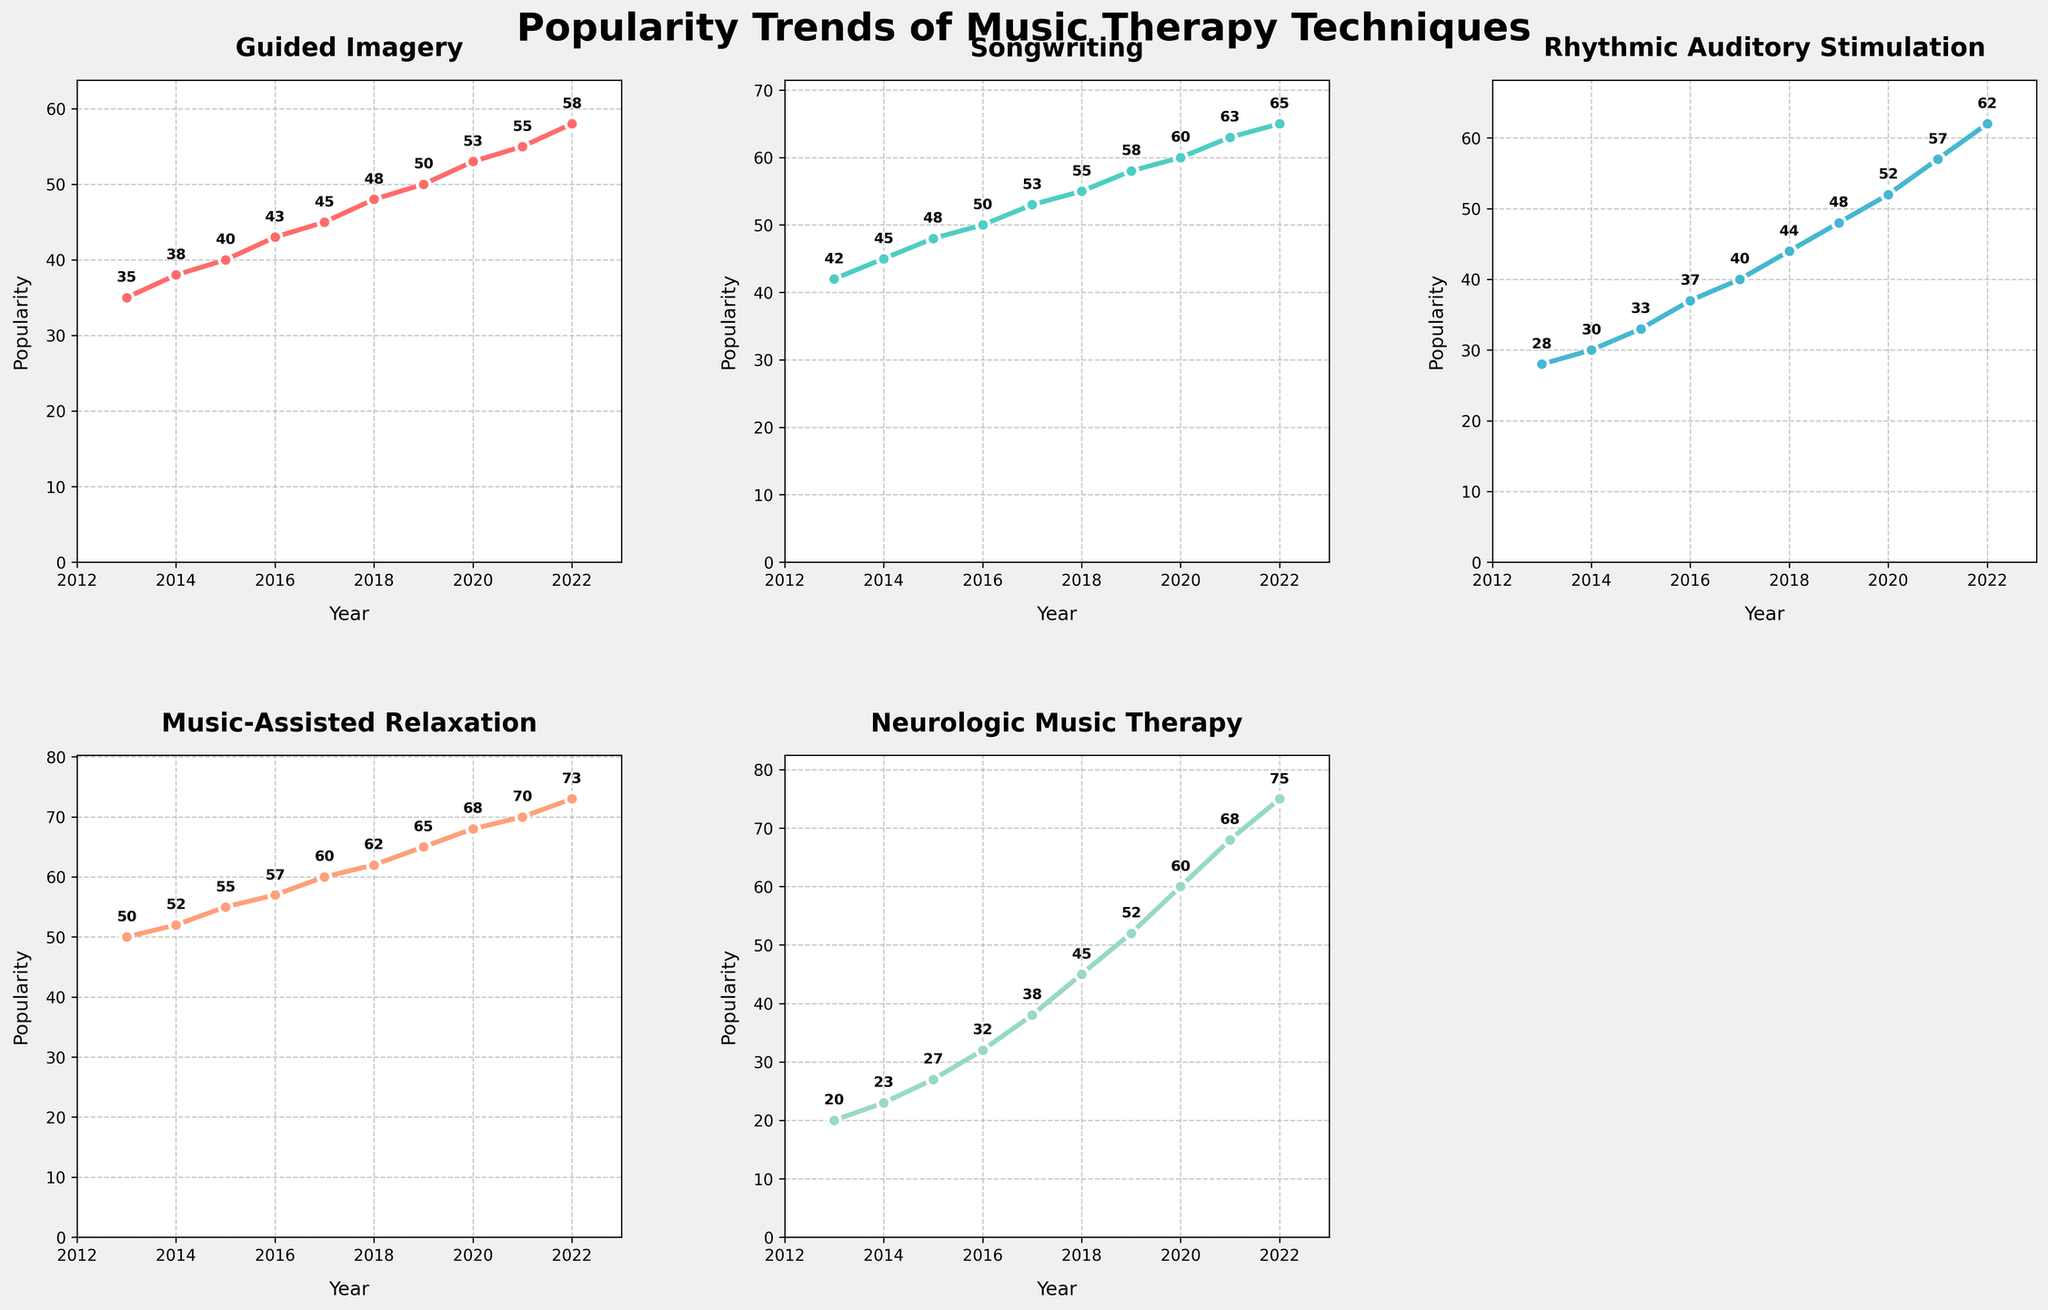what is the popularity of Guided Imagery in 2017? Guided Imagery is plotted on the top-left subplot. According to the plot, in 2017, the popularity is at the value marked on the line which is 45.
Answer: 45 What trend do you observe in the popularity of Rhythmic Auditory Stimulation from 2013 to 2022? The values increase steadily every year, showing a consistent upward trend in popularity.
Answer: Upward trend Which music therapy technique became most popular in 2022? By looking at all subplots and comparing the heights of the lines in 2022, which correspond to the y-axis values, Music-Assisted Relaxation tops out at 73.
Answer: Music-Assisted Relaxation Which year saw the fastest growth in popularity for Neurologic Music Therapy? Checking the slope of the line for Neurologic Music Therapy, 2020 to 2021 shows the fastest growth as it has the steepest increase from 60 to 68, a change of 8.
Answer: 2020-2021 Which technique had the most consistent growth over the period? Consistent growth can be identified by the smoothness of the line without large jumps. Neurologic Music Therapy shows a steady increase every year with no dramatic changes.
Answer: Neurologic Music Therapy By how much did Songwriting’s popularity grow from 2013 to 2022? The starting point in 2013 for Songwriting is 42, and in 2022 it is 65. The growth amount is 65 - 42.
Answer: 23 Which technique has the lowest popularity value in 2013, and what is it? By looking at the y-values for the year 2013 across all subplots, Neurologic Music Therapy has the lowest with a value of 20.
Answer: Neurologic Music Therapy, 20 What is the average popularity of Music-Assisted Relaxation over the decade? Summing the yearly popularity values for Music-Assisted Relaxation and dividing by the number of years (10), we have (50+52+55+57+60+62+65+68+70+73)/10.
Answer: 61.2 Comparing the trends for Guided Imagery and Songwriting, which one had a steeper overall increase? Calculating the difference from 2013 to 2022 for both techniques, Guided Imagery increased by 23 (58-35) and Songwriting by 23 (65-42). Both had equal increases.
Answer: Both had equal increases Among all techniques, which year had the least total popularity combined? Adding the popularity values of all techniques for each year, the sums are:
2013: 35+42+28+50+20=175,
2014: ..., 
2022:...,
2013 has the lowest sum of 175.
Answer: 2013 